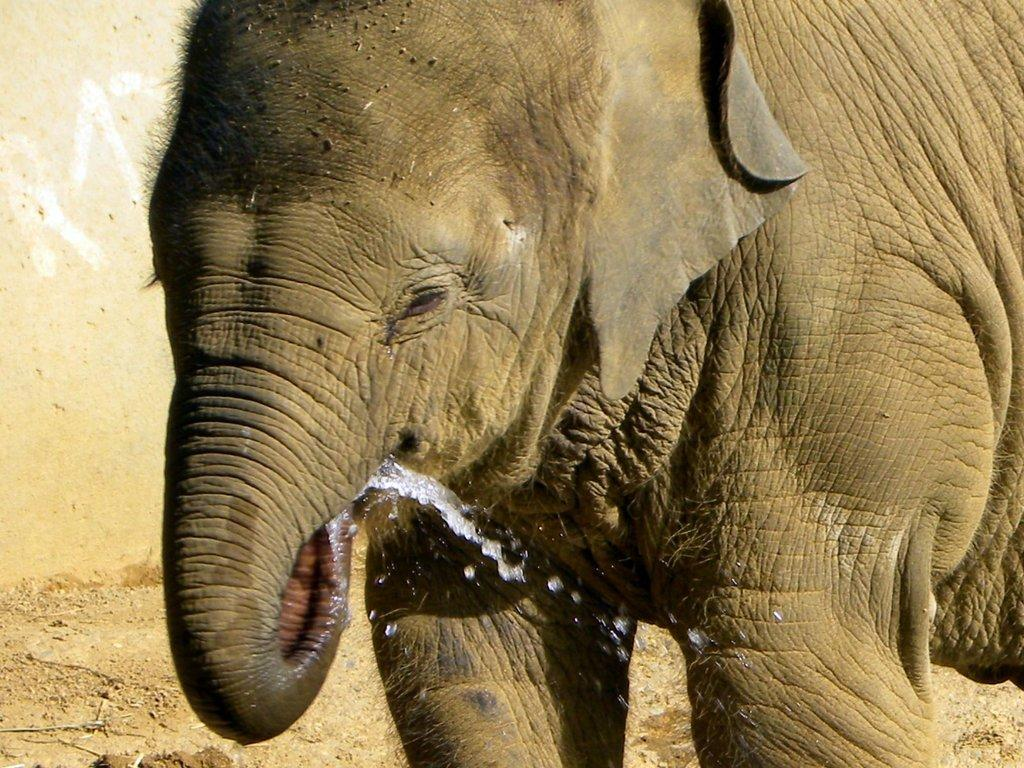What is the main subject in the foreground of the picture? There is an elephant in the foreground of the picture. What is the elephant doing in the picture? The elephant is drinking water using its trunk. What can be seen in the background of the picture? There is a wall in the background of the picture. What type of instrument is the elephant playing in the picture? There is no instrument present in the image, and the elephant is not playing any instrument. 